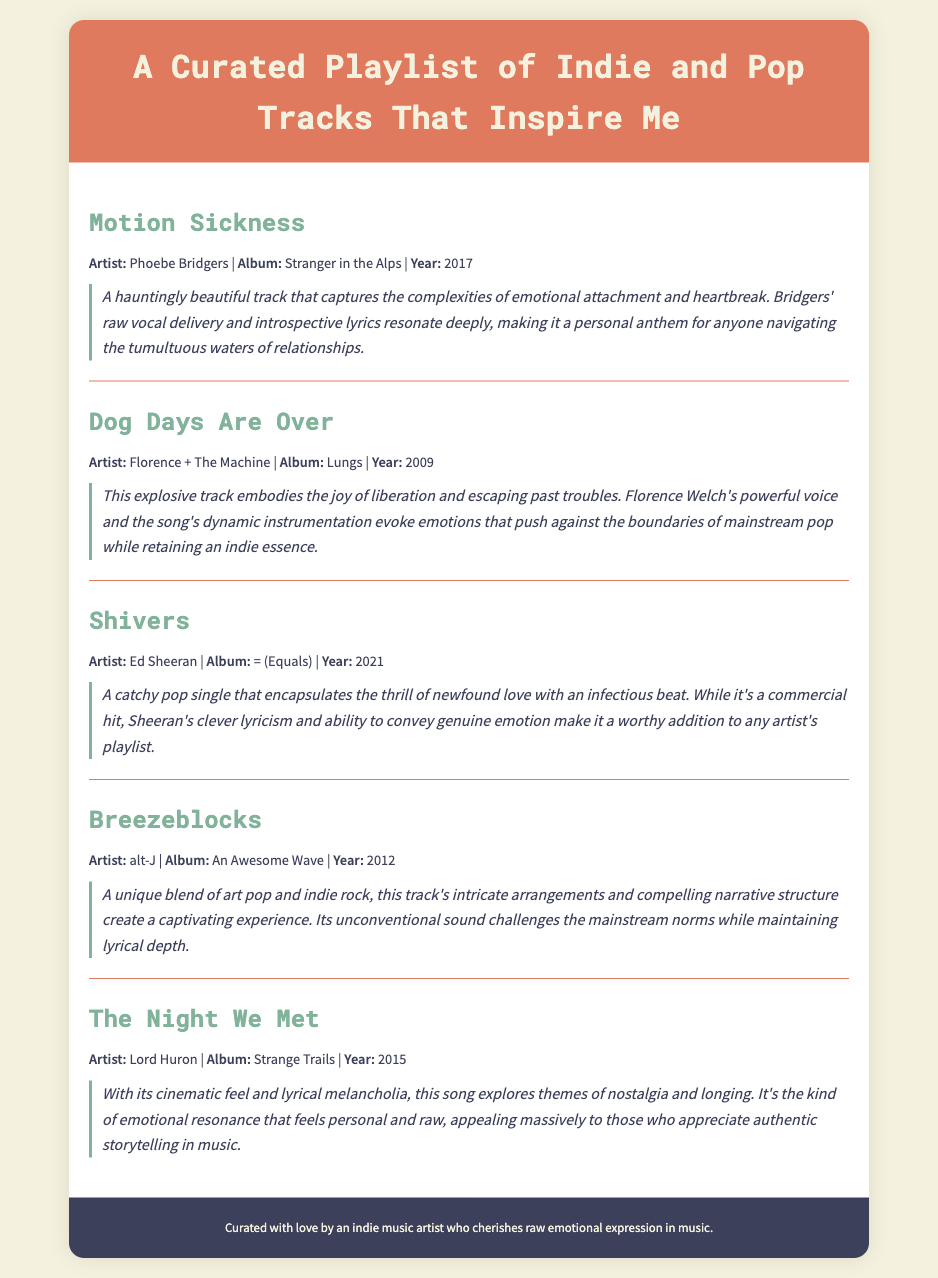What is the title of the playlist? The title of the playlist is provided at the top of the document, which is "A Curated Playlist of Indie and Pop Tracks That Inspire Me."
Answer: A Curated Playlist of Indie and Pop Tracks That Inspire Me Who is the artist for the track "Shivers"? The artist for the track "Shivers" is mentioned in the track information section.
Answer: Ed Sheeran What year was "Dog Days Are Over" released? The release year for "Dog Days Are Over" is included in the track's information.
Answer: 2009 Which track discusses themes of nostalgia and longing? The annotation for the track provides insights into its themes, and "The Night We Met" is the related track.
Answer: The Night We Met How many tracks are listed in the playlist? The total number of tracks can be counted from the document content, which lists five individual tracks.
Answer: 5 Which artist's song is described as a commercial hit? The annotation refers to "Shivers" as a catchy pop single and mentions it being a commercial hit.
Answer: Ed Sheeran What genre does the track "Breezeblocks" represent? The description of the track provides insight into its genre, which blends art pop and indie rock.
Answer: Art pop and indie rock What is the primary emotion conveyed in "Motion Sickness"? The annotation highlights the emotional complexities captured in this song, focusing on emotional attachment and heartbreak.
Answer: Heartbreak 